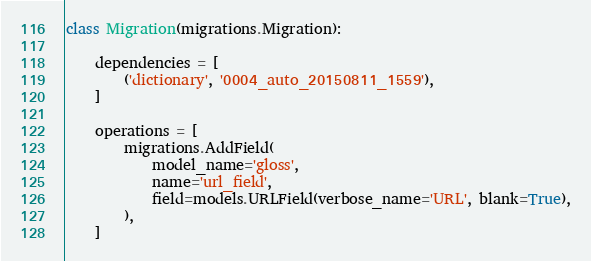<code> <loc_0><loc_0><loc_500><loc_500><_Python_>

class Migration(migrations.Migration):

    dependencies = [
        ('dictionary', '0004_auto_20150811_1559'),
    ]

    operations = [
        migrations.AddField(
            model_name='gloss',
            name='url_field',
            field=models.URLField(verbose_name='URL', blank=True),
        ),
    ]
</code> 